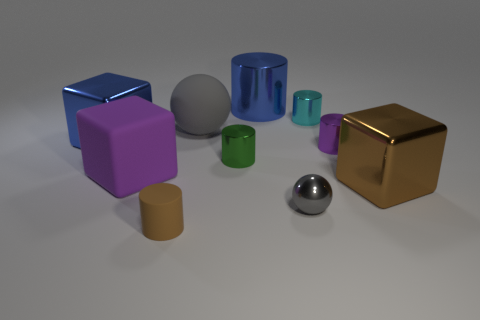Subtract all brown cylinders. How many cylinders are left? 4 Subtract all brown matte cylinders. How many cylinders are left? 4 Subtract all red cylinders. Subtract all yellow spheres. How many cylinders are left? 5 Subtract all blocks. How many objects are left? 7 Subtract all tiny balls. Subtract all small brown cylinders. How many objects are left? 8 Add 7 purple objects. How many purple objects are left? 9 Add 3 green metallic objects. How many green metallic objects exist? 4 Subtract 0 red cylinders. How many objects are left? 10 